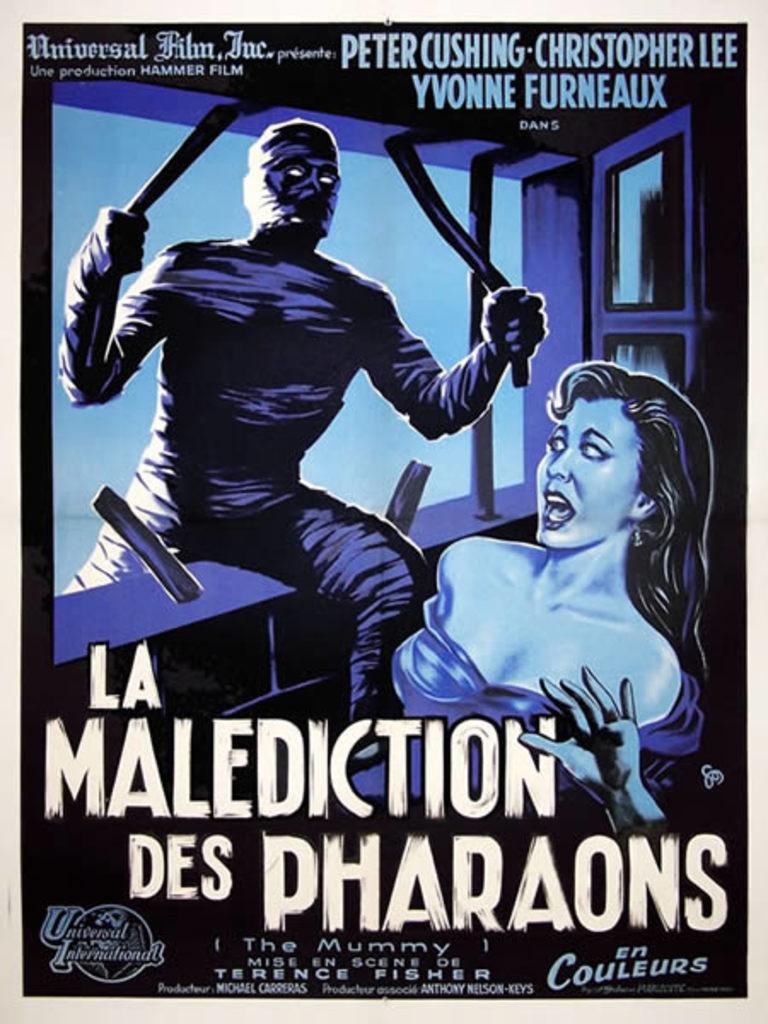Which company produced la malediction des pharaons?
Offer a very short reply. Hammer film. What is the name of one of the actors or actresses in this?
Provide a short and direct response. Peter cushing. 